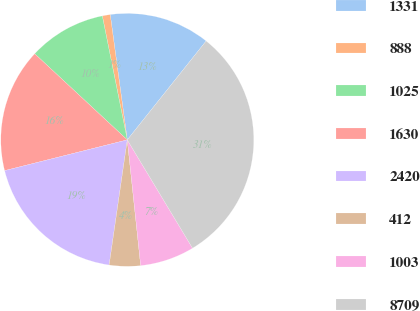Convert chart to OTSL. <chart><loc_0><loc_0><loc_500><loc_500><pie_chart><fcel>1331<fcel>888<fcel>1025<fcel>1630<fcel>2420<fcel>412<fcel>1003<fcel>8709<nl><fcel>12.87%<fcel>1.01%<fcel>9.91%<fcel>15.84%<fcel>18.8%<fcel>3.98%<fcel>6.94%<fcel>30.66%<nl></chart> 